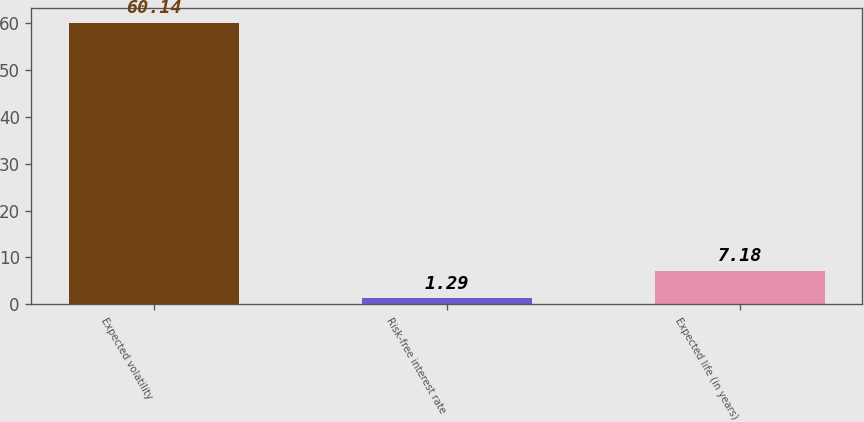Convert chart to OTSL. <chart><loc_0><loc_0><loc_500><loc_500><bar_chart><fcel>Expected volatility<fcel>Risk-free interest rate<fcel>Expected life (in years)<nl><fcel>60.14<fcel>1.29<fcel>7.18<nl></chart> 